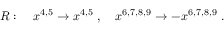Convert formula to latex. <formula><loc_0><loc_0><loc_500><loc_500>R \colon \quad x ^ { 4 , 5 } \to x ^ { 4 , 5 } \ , \quad x ^ { 6 , 7 , 8 , 9 } \to - x ^ { 6 , 7 , 8 , 9 } \ .</formula> 